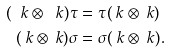Convert formula to latex. <formula><loc_0><loc_0><loc_500><loc_500>( \ k \otimes \ k ) \tau & = \tau ( \ k \otimes \ k ) \\ ( \ k \otimes \ k ) \sigma & = \sigma ( \ k \otimes \ k ) .</formula> 